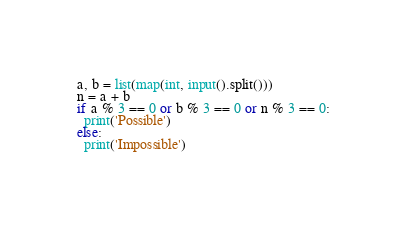Convert code to text. <code><loc_0><loc_0><loc_500><loc_500><_Python_>a, b = list(map(int, input().split()))
n = a + b
if a % 3 == 0 or b % 3 == 0 or n % 3 == 0:
  print('Possible')
else:
  print('Impossible')</code> 